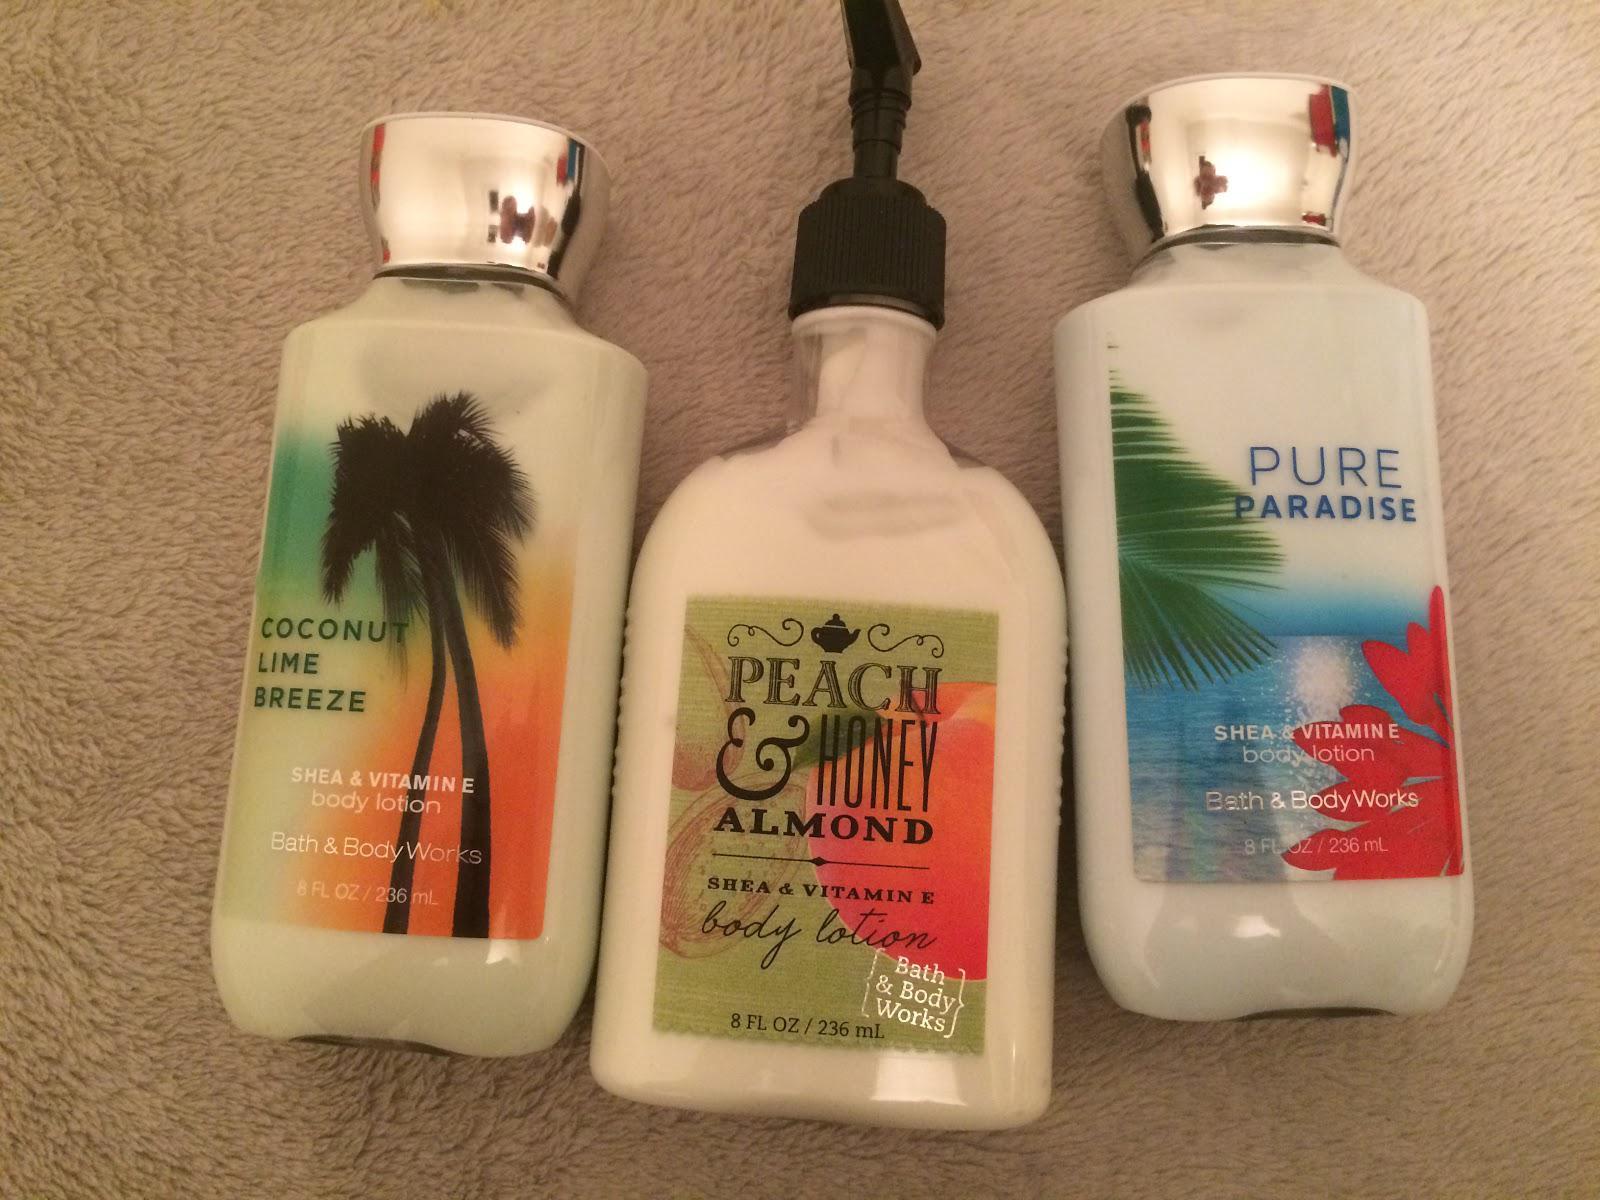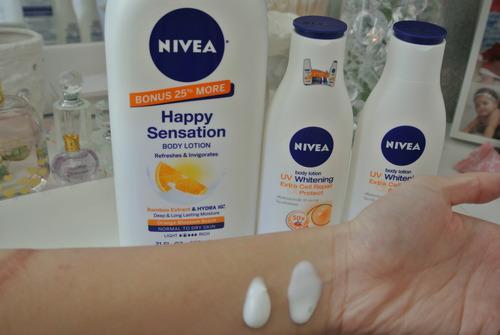The first image is the image on the left, the second image is the image on the right. For the images shown, is this caption "Left image contains no more than 2 lotion products." true? Answer yes or no. No. 